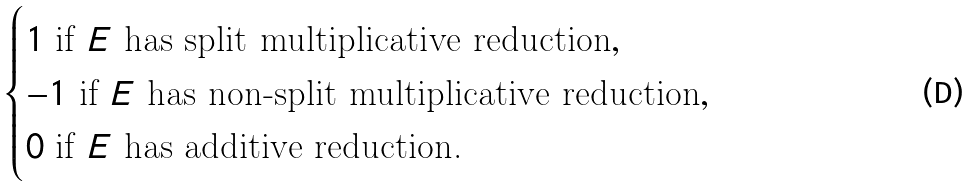<formula> <loc_0><loc_0><loc_500><loc_500>\begin{cases} 1 \text { if } E \text { has split multiplicative reduction} , \\ - 1 \text { if } E \text { has non-split multiplicative reduction} , \\ 0 \text { if } E \text { has additive reduction.} \end{cases}</formula> 